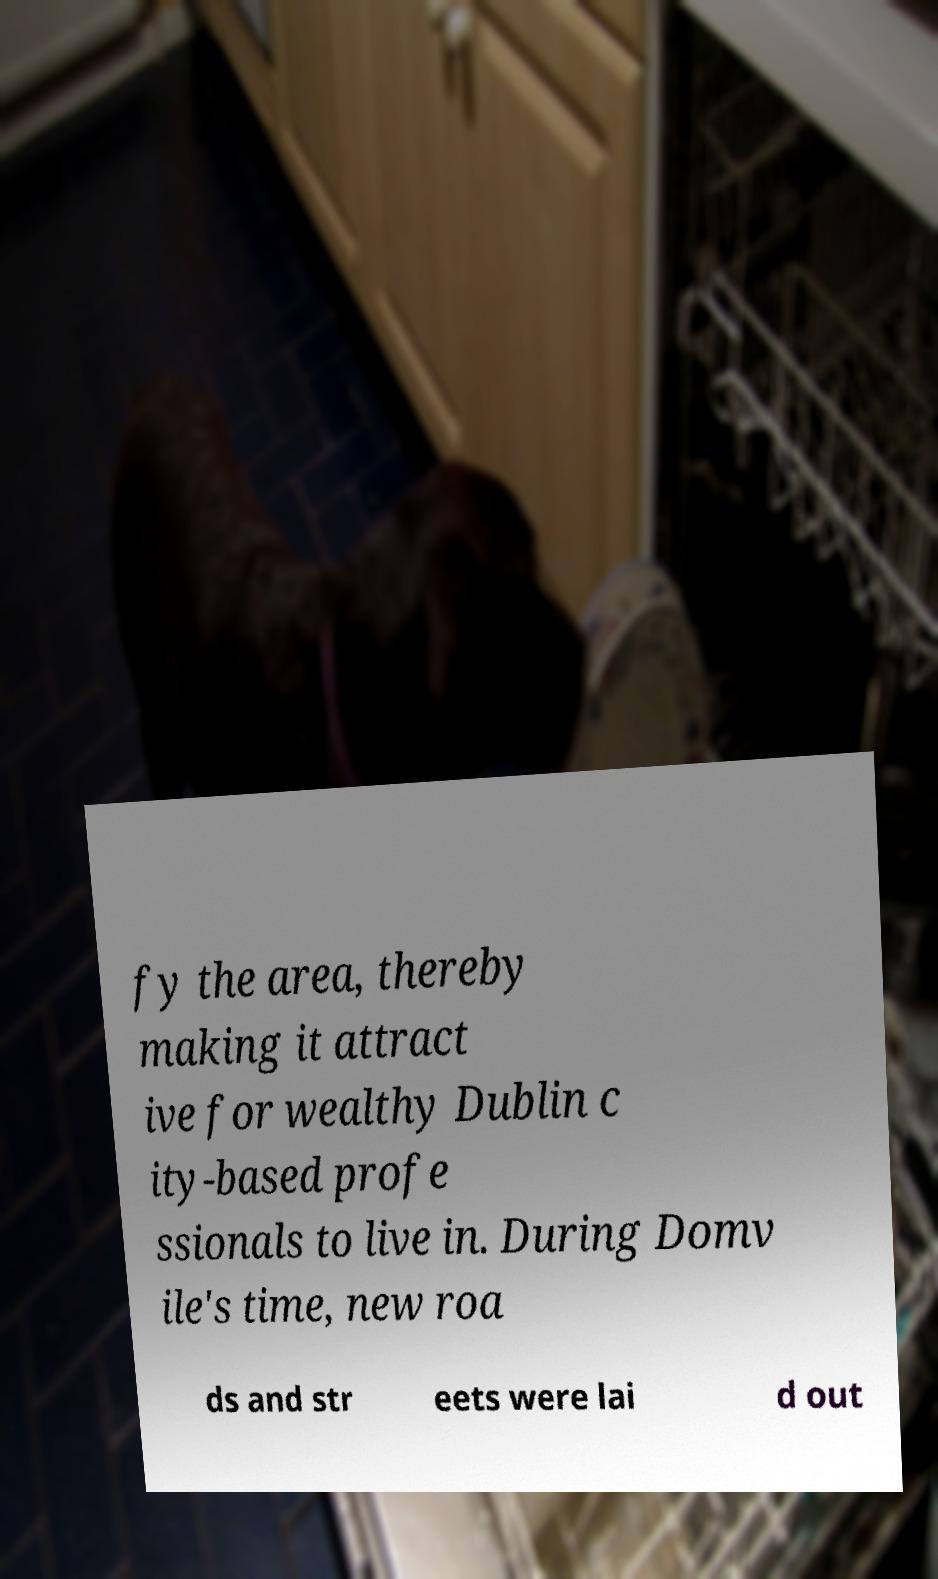I need the written content from this picture converted into text. Can you do that? fy the area, thereby making it attract ive for wealthy Dublin c ity-based profe ssionals to live in. During Domv ile's time, new roa ds and str eets were lai d out 